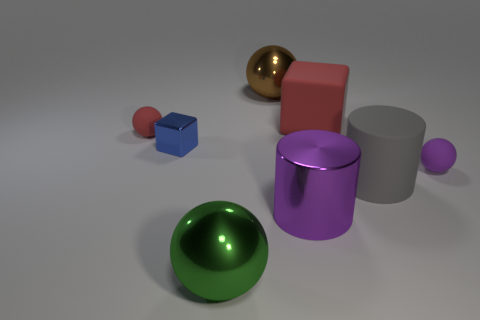Subtract all gray balls. Subtract all yellow cylinders. How many balls are left? 4 Add 1 cylinders. How many objects exist? 9 Subtract all cylinders. How many objects are left? 6 Subtract all small cyan metallic blocks. Subtract all large rubber things. How many objects are left? 6 Add 4 green metal spheres. How many green metal spheres are left? 5 Add 7 large gray metal cubes. How many large gray metal cubes exist? 7 Subtract 0 cyan spheres. How many objects are left? 8 